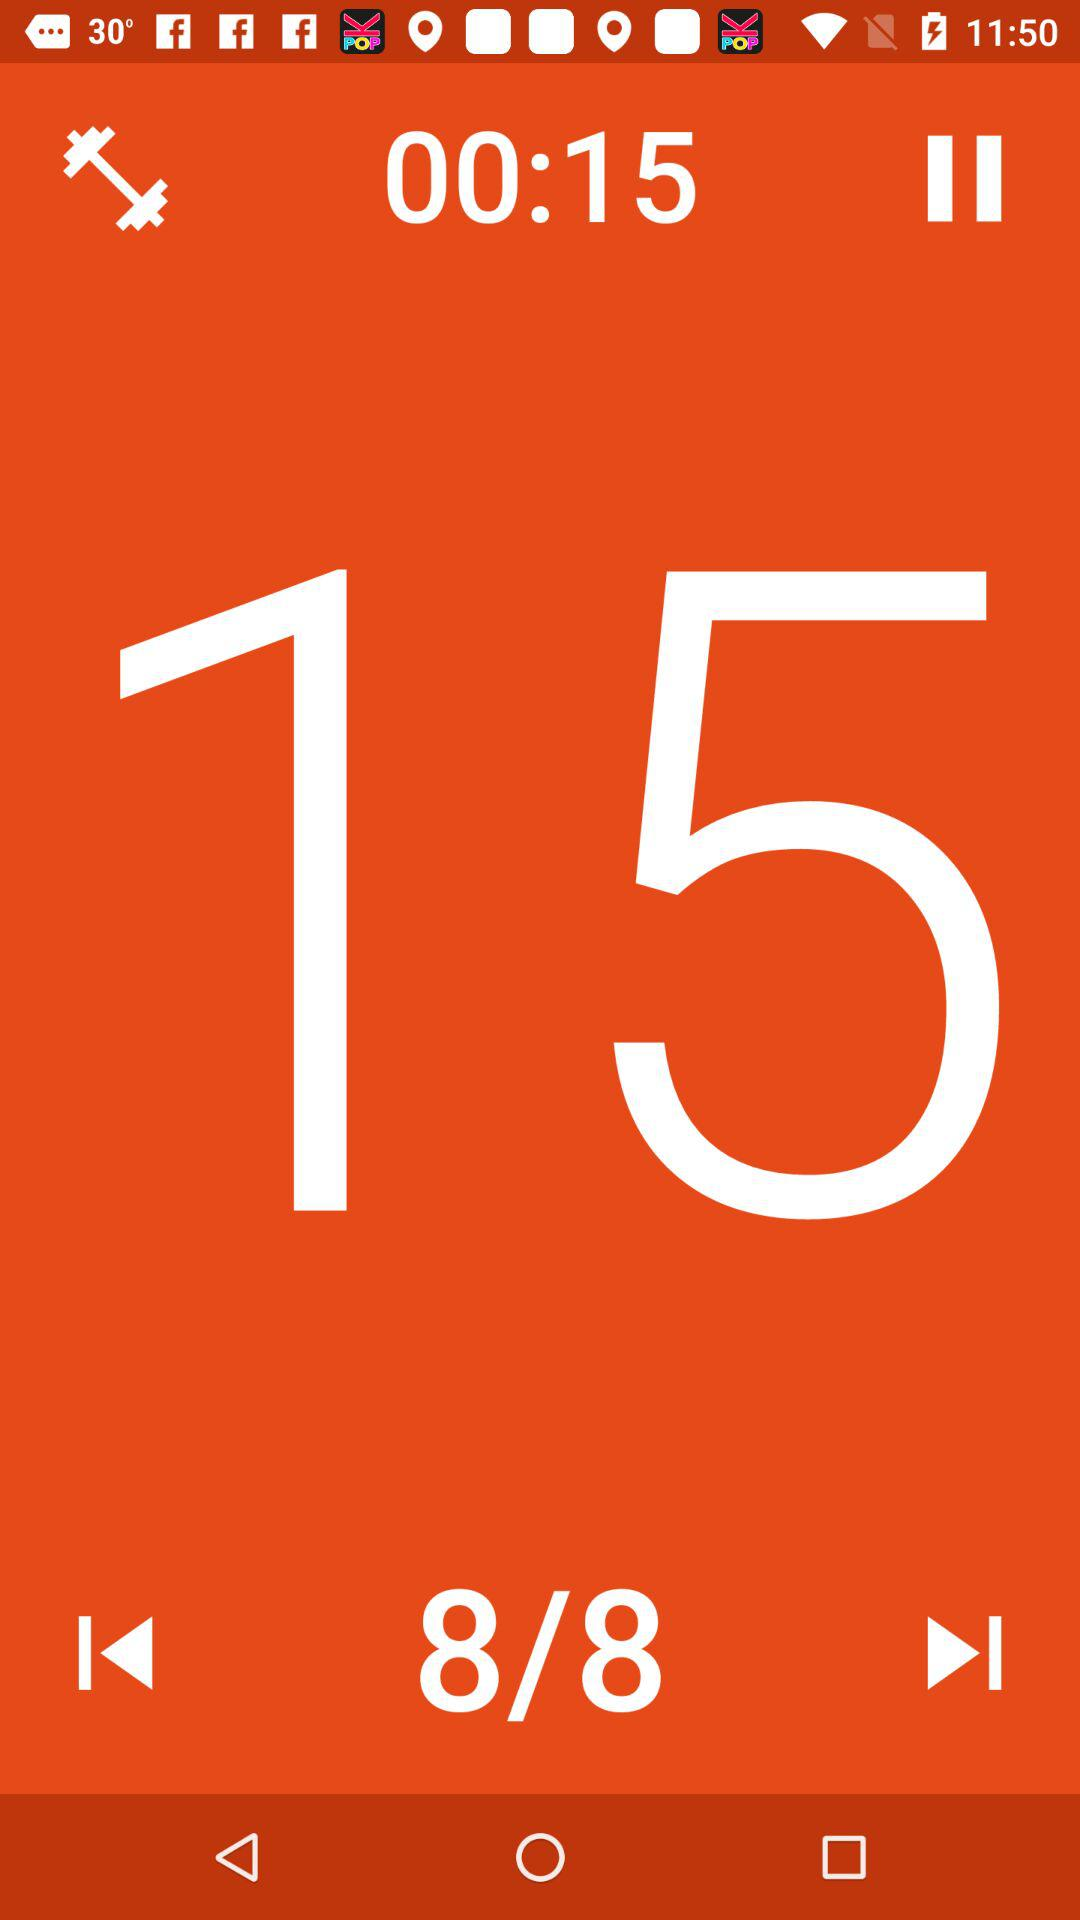What is the workout duration? The workout duration is 15 seconds. 